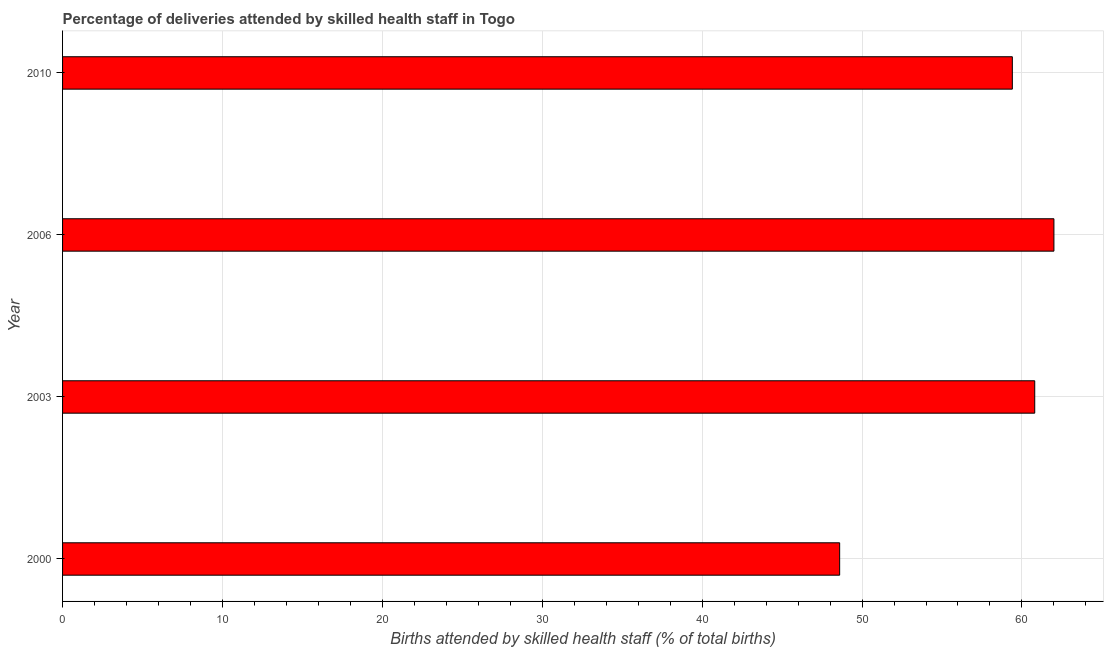Does the graph contain any zero values?
Offer a terse response. No. Does the graph contain grids?
Ensure brevity in your answer.  Yes. What is the title of the graph?
Your answer should be very brief. Percentage of deliveries attended by skilled health staff in Togo. What is the label or title of the X-axis?
Provide a short and direct response. Births attended by skilled health staff (% of total births). What is the number of births attended by skilled health staff in 2010?
Offer a very short reply. 59.4. Across all years, what is the maximum number of births attended by skilled health staff?
Offer a terse response. 62. Across all years, what is the minimum number of births attended by skilled health staff?
Offer a very short reply. 48.6. What is the sum of the number of births attended by skilled health staff?
Provide a short and direct response. 230.8. What is the average number of births attended by skilled health staff per year?
Ensure brevity in your answer.  57.7. What is the median number of births attended by skilled health staff?
Offer a terse response. 60.1. In how many years, is the number of births attended by skilled health staff greater than 6 %?
Provide a succinct answer. 4. Do a majority of the years between 2003 and 2000 (inclusive) have number of births attended by skilled health staff greater than 34 %?
Provide a succinct answer. No. What is the ratio of the number of births attended by skilled health staff in 2000 to that in 2010?
Your answer should be compact. 0.82. Is the number of births attended by skilled health staff in 2003 less than that in 2006?
Make the answer very short. Yes. Is the sum of the number of births attended by skilled health staff in 2003 and 2006 greater than the maximum number of births attended by skilled health staff across all years?
Your answer should be very brief. Yes. In how many years, is the number of births attended by skilled health staff greater than the average number of births attended by skilled health staff taken over all years?
Offer a very short reply. 3. How many bars are there?
Offer a terse response. 4. How many years are there in the graph?
Your answer should be very brief. 4. What is the Births attended by skilled health staff (% of total births) of 2000?
Offer a terse response. 48.6. What is the Births attended by skilled health staff (% of total births) of 2003?
Offer a terse response. 60.8. What is the Births attended by skilled health staff (% of total births) of 2006?
Your answer should be very brief. 62. What is the Births attended by skilled health staff (% of total births) of 2010?
Offer a terse response. 59.4. What is the difference between the Births attended by skilled health staff (% of total births) in 2000 and 2003?
Keep it short and to the point. -12.2. What is the difference between the Births attended by skilled health staff (% of total births) in 2000 and 2006?
Your response must be concise. -13.4. What is the difference between the Births attended by skilled health staff (% of total births) in 2003 and 2010?
Your answer should be compact. 1.4. What is the ratio of the Births attended by skilled health staff (% of total births) in 2000 to that in 2003?
Your response must be concise. 0.8. What is the ratio of the Births attended by skilled health staff (% of total births) in 2000 to that in 2006?
Keep it short and to the point. 0.78. What is the ratio of the Births attended by skilled health staff (% of total births) in 2000 to that in 2010?
Ensure brevity in your answer.  0.82. What is the ratio of the Births attended by skilled health staff (% of total births) in 2003 to that in 2006?
Make the answer very short. 0.98. What is the ratio of the Births attended by skilled health staff (% of total births) in 2006 to that in 2010?
Provide a short and direct response. 1.04. 